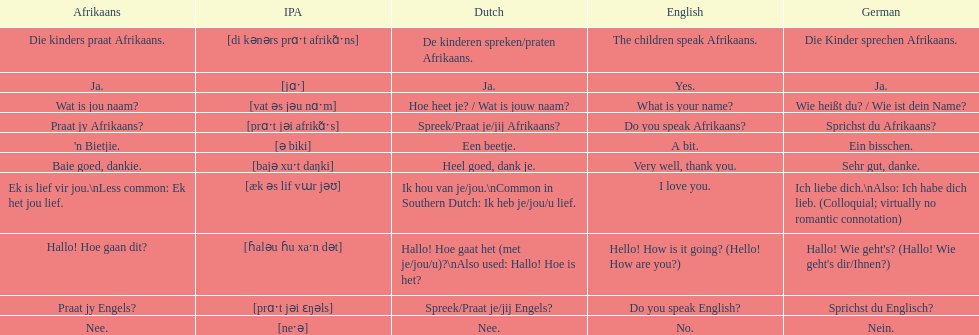How do you say 'do you speak afrikaans?' in afrikaans? Praat jy Afrikaans?. 